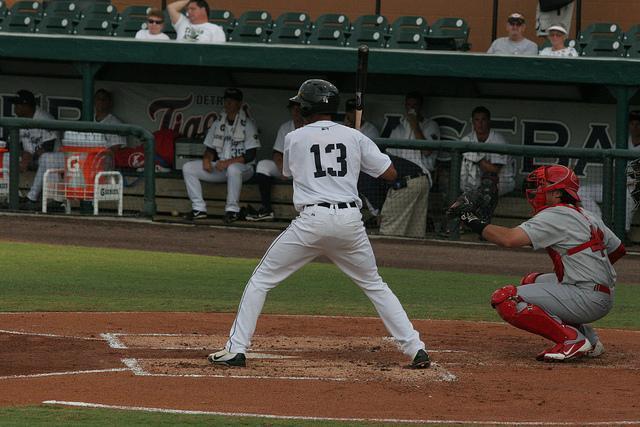How many people are there?
Give a very brief answer. 8. 